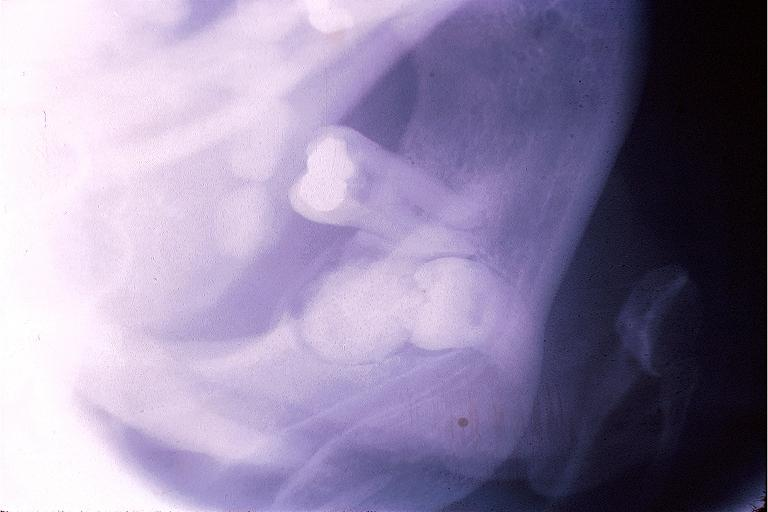does muscle atrophy show complex odontoma?
Answer the question using a single word or phrase. No 